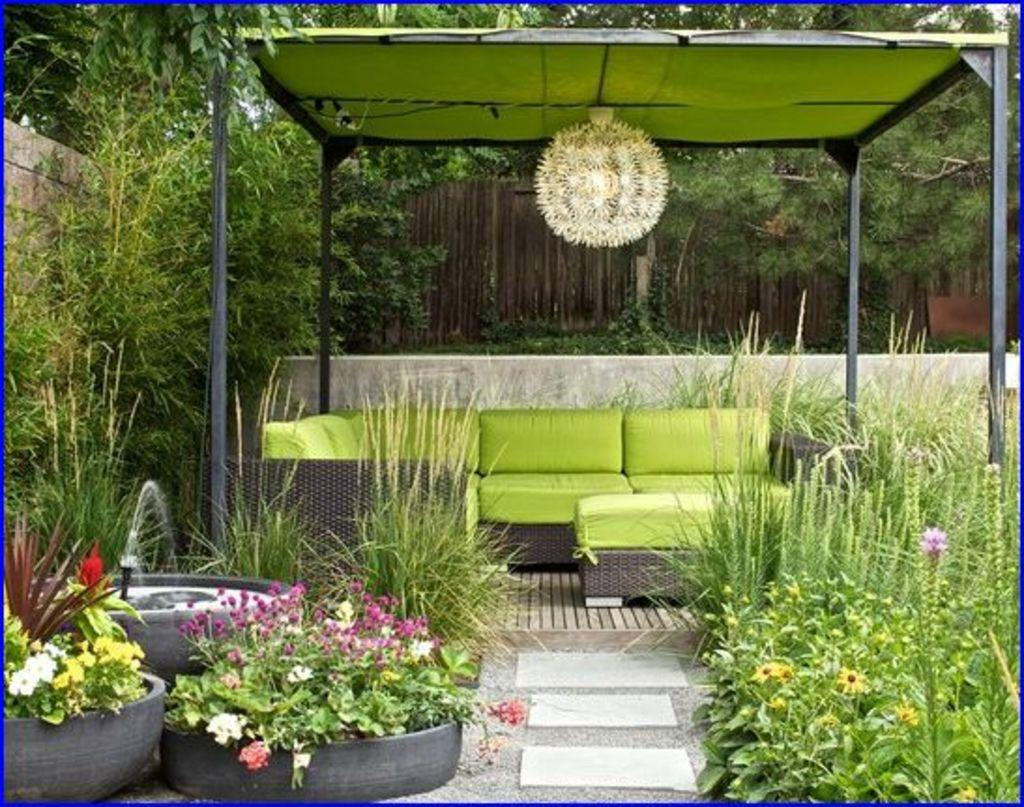What type of vegetation can be seen in the image? There are many trees, plants, and grass in the image. Are there any flowers visible in the image? Yes, there are flowers on pot plants in the image. What structure is attached to the roof in the image? There is a light attached to the roof in the image. How many walls are present in the image? There are two walls in the image. What type of furniture can be seen in the image? There is a sofa on a surface in the image. What is the answer to the riddle written on the wall in the image? There is no riddle written on the wall in the image. Which direction is the north wall facing in the image? There is no indication of the direction the walls are facing in the image. 